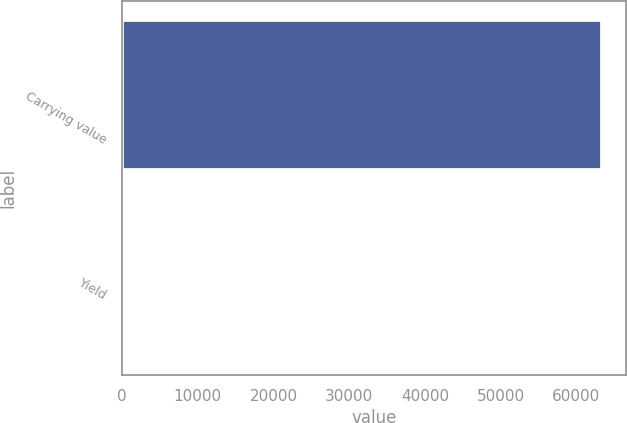<chart> <loc_0><loc_0><loc_500><loc_500><bar_chart><fcel>Carrying value<fcel>Yield<nl><fcel>63434<fcel>2.35<nl></chart> 